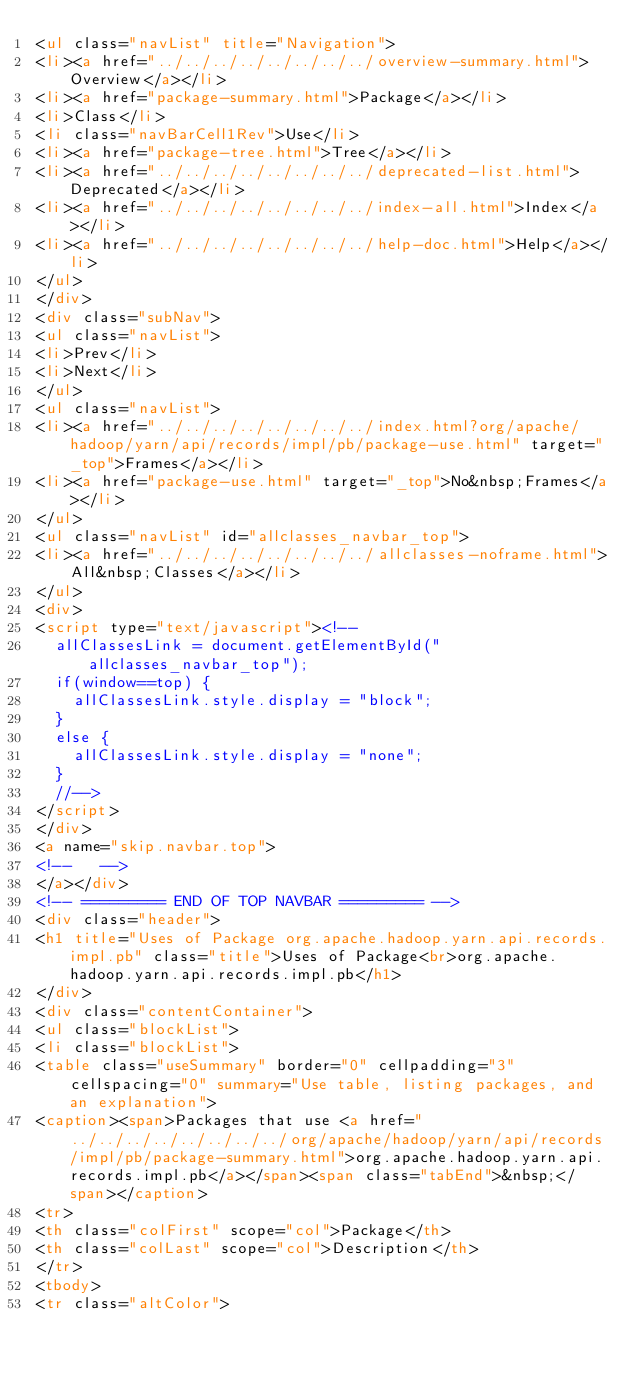Convert code to text. <code><loc_0><loc_0><loc_500><loc_500><_HTML_><ul class="navList" title="Navigation">
<li><a href="../../../../../../../../overview-summary.html">Overview</a></li>
<li><a href="package-summary.html">Package</a></li>
<li>Class</li>
<li class="navBarCell1Rev">Use</li>
<li><a href="package-tree.html">Tree</a></li>
<li><a href="../../../../../../../../deprecated-list.html">Deprecated</a></li>
<li><a href="../../../../../../../../index-all.html">Index</a></li>
<li><a href="../../../../../../../../help-doc.html">Help</a></li>
</ul>
</div>
<div class="subNav">
<ul class="navList">
<li>Prev</li>
<li>Next</li>
</ul>
<ul class="navList">
<li><a href="../../../../../../../../index.html?org/apache/hadoop/yarn/api/records/impl/pb/package-use.html" target="_top">Frames</a></li>
<li><a href="package-use.html" target="_top">No&nbsp;Frames</a></li>
</ul>
<ul class="navList" id="allclasses_navbar_top">
<li><a href="../../../../../../../../allclasses-noframe.html">All&nbsp;Classes</a></li>
</ul>
<div>
<script type="text/javascript"><!--
  allClassesLink = document.getElementById("allclasses_navbar_top");
  if(window==top) {
    allClassesLink.style.display = "block";
  }
  else {
    allClassesLink.style.display = "none";
  }
  //-->
</script>
</div>
<a name="skip.navbar.top">
<!--   -->
</a></div>
<!-- ========= END OF TOP NAVBAR ========= -->
<div class="header">
<h1 title="Uses of Package org.apache.hadoop.yarn.api.records.impl.pb" class="title">Uses of Package<br>org.apache.hadoop.yarn.api.records.impl.pb</h1>
</div>
<div class="contentContainer">
<ul class="blockList">
<li class="blockList">
<table class="useSummary" border="0" cellpadding="3" cellspacing="0" summary="Use table, listing packages, and an explanation">
<caption><span>Packages that use <a href="../../../../../../../../org/apache/hadoop/yarn/api/records/impl/pb/package-summary.html">org.apache.hadoop.yarn.api.records.impl.pb</a></span><span class="tabEnd">&nbsp;</span></caption>
<tr>
<th class="colFirst" scope="col">Package</th>
<th class="colLast" scope="col">Description</th>
</tr>
<tbody>
<tr class="altColor"></code> 